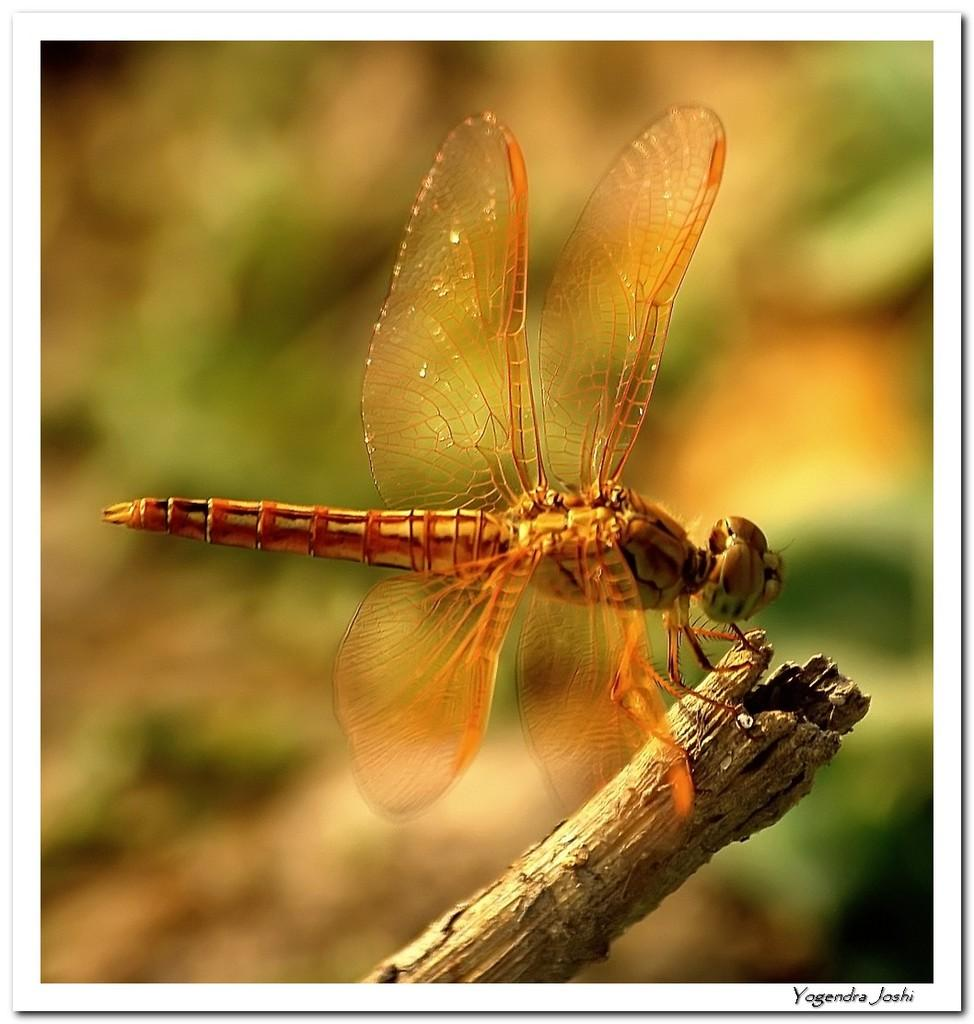What type of creature is present in the image? There is an insect in the image. What is the insect resting on? The insect is on a wooden stick. Can you describe the background of the image? The background of the image is blurry. What type of bead is hanging from the beam in the image? There is no bead or beam present in the image; it only features an insect on a wooden stick with a blurry background. 